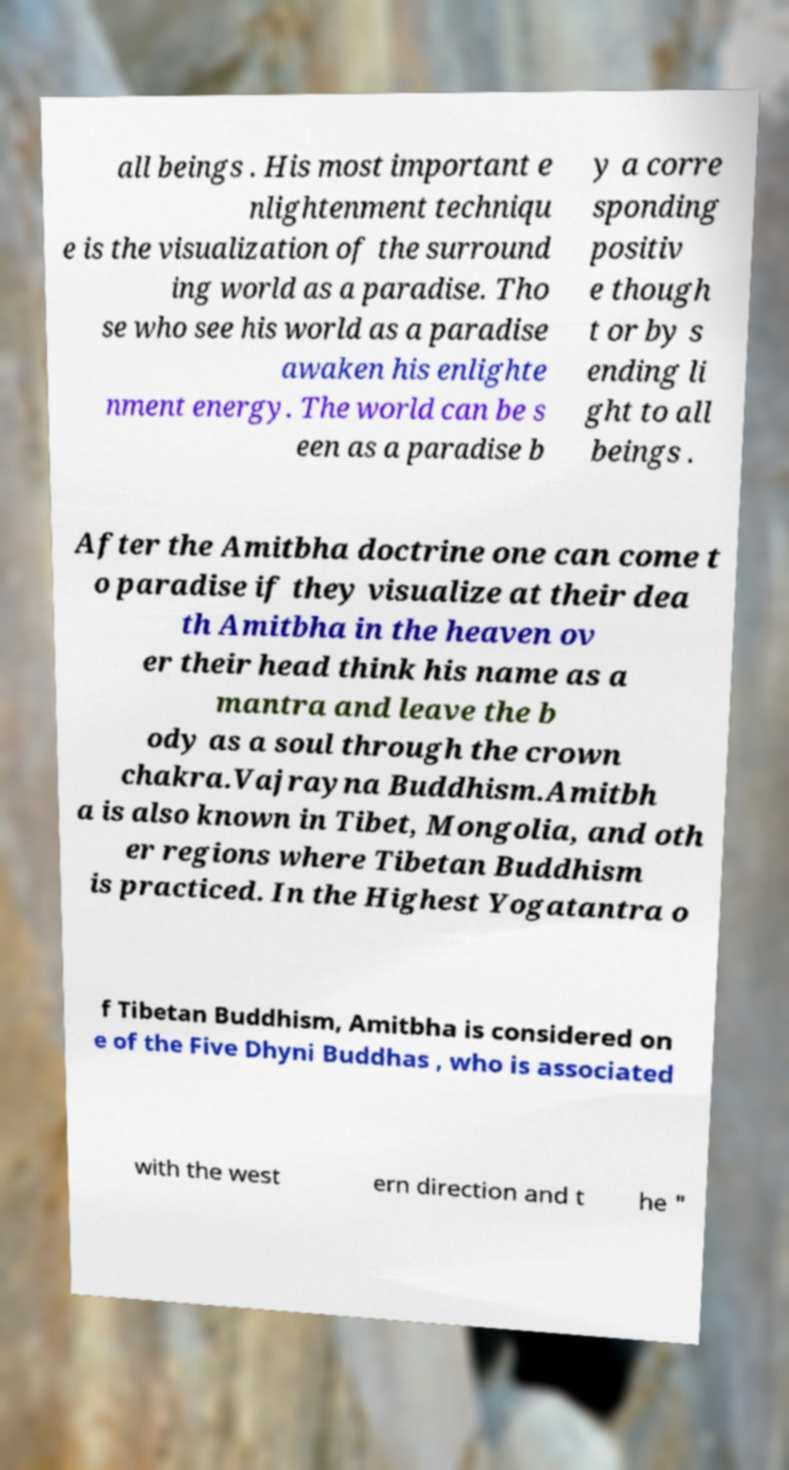Can you read and provide the text displayed in the image?This photo seems to have some interesting text. Can you extract and type it out for me? all beings . His most important e nlightenment techniqu e is the visualization of the surround ing world as a paradise. Tho se who see his world as a paradise awaken his enlighte nment energy. The world can be s een as a paradise b y a corre sponding positiv e though t or by s ending li ght to all beings . After the Amitbha doctrine one can come t o paradise if they visualize at their dea th Amitbha in the heaven ov er their head think his name as a mantra and leave the b ody as a soul through the crown chakra.Vajrayna Buddhism.Amitbh a is also known in Tibet, Mongolia, and oth er regions where Tibetan Buddhism is practiced. In the Highest Yogatantra o f Tibetan Buddhism, Amitbha is considered on e of the Five Dhyni Buddhas , who is associated with the west ern direction and t he " 